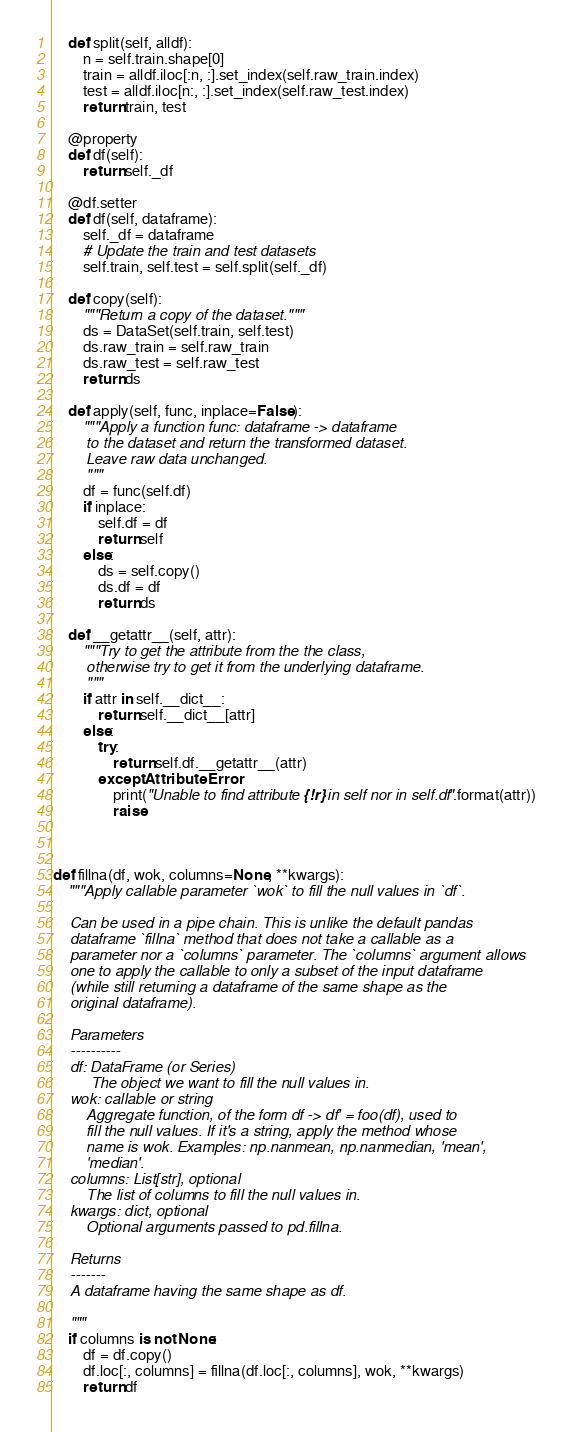Convert code to text. <code><loc_0><loc_0><loc_500><loc_500><_Python_>    def split(self, alldf):
        n = self.train.shape[0]
        train = alldf.iloc[:n, :].set_index(self.raw_train.index)
        test = alldf.iloc[n:, :].set_index(self.raw_test.index)
        return train, test

    @property
    def df(self):
        return self._df

    @df.setter
    def df(self, dataframe):
        self._df = dataframe
        # Update the train and test datasets
        self.train, self.test = self.split(self._df)

    def copy(self):
        """Return a copy of the dataset."""
        ds = DataSet(self.train, self.test)
        ds.raw_train = self.raw_train
        ds.raw_test = self.raw_test
        return ds

    def apply(self, func, inplace=False):
        """Apply a function func: dataframe -> dataframe
        to the dataset and return the transformed dataset.
        Leave raw data unchanged.
        """
        df = func(self.df)
        if inplace:
            self.df = df
            return self
        else:
            ds = self.copy()
            ds.df = df
            return ds

    def __getattr__(self, attr):
        """Try to get the attribute from the the class,
        otherwise try to get it from the underlying dataframe.
        """
        if attr in self.__dict__:
            return self.__dict__[attr]
        else:
            try:
                return self.df.__getattr__(attr)
            except AttributeError:
                print("Unable to find attribute {!r} in self nor in self.df".format(attr))
                raise



def fillna(df, wok, columns=None, **kwargs):
    """Apply callable parameter `wok` to fill the null values in `df`.

    Can be used in a pipe chain. This is unlike the default pandas
    dataframe `fillna` method that does not take a callable as a
    parameter nor a `columns` parameter. The `columns` argument allows
    one to apply the callable to only a subset of the input dataframe
    (while still returning a dataframe of the same shape as the
    original dataframe).

    Parameters
    ----------
    df: DataFrame (or Series)
         The object we want to fill the null values in.
    wok: callable or string
        Aggregate function, of the form df -> df' = foo(df), used to
        fill the null values. If it's a string, apply the method whose
        name is wok. Examples: np.nanmean, np.nanmedian, 'mean',
        'median'.
    columns: List[str], optional
        The list of columns to fill the null values in.
    kwargs: dict, optional
        Optional arguments passed to pd.fillna.

    Returns
    -------
    A dataframe having the same shape as df.

    """
    if columns is not None:
        df = df.copy()
        df.loc[:, columns] = fillna(df.loc[:, columns], wok, **kwargs)
        return df
</code> 